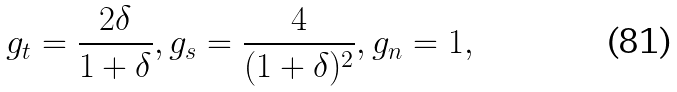Convert formula to latex. <formula><loc_0><loc_0><loc_500><loc_500>g _ { t } = \frac { 2 \delta } { 1 + \delta } , g _ { s } = \frac { 4 } { ( 1 + \delta ) ^ { 2 } } , g _ { n } = 1 ,</formula> 